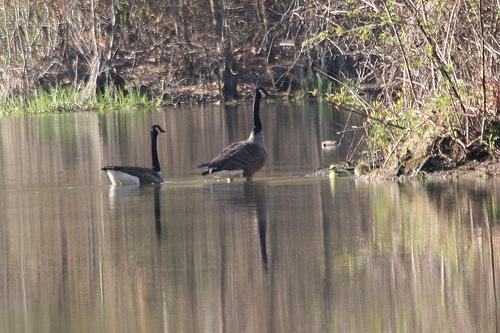Question: what animal is pictured?
Choices:
A. Goose.
B. Dog.
C. Horse.
D. Cat.
Answer with the letter. Answer: A Question: what are the geese doing?
Choices:
A. Running.
B. Swimming.
C. Walking.
D. Standing still.
Answer with the letter. Answer: B Question: what is the weather in the photo?
Choices:
A. Sunny.
B. Overcast.
C. Stormy.
D. Snowing.
Answer with the letter. Answer: A Question: what is the color of the lake?
Choices:
A. Brown.
B. Blue.
C. Green.
D. Tan.
Answer with the letter. Answer: A Question: what color are the geese's necks?
Choices:
A. White.
B. Brown.
C. Green.
D. Black.
Answer with the letter. Answer: D Question: where are the geese swimming?
Choices:
A. In the creek.
B. In a lake.
C. In the river.
D. In the pool.
Answer with the letter. Answer: B Question: who is leading?
Choices:
A. The man.
B. The woman.
C. The goose on the right.
D. The dog.
Answer with the letter. Answer: C 